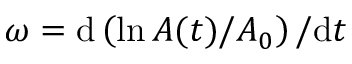<formula> <loc_0><loc_0><loc_500><loc_500>\omega = d \left ( \ln { A ( t ) } / { A _ { 0 } } \right ) / d t</formula> 